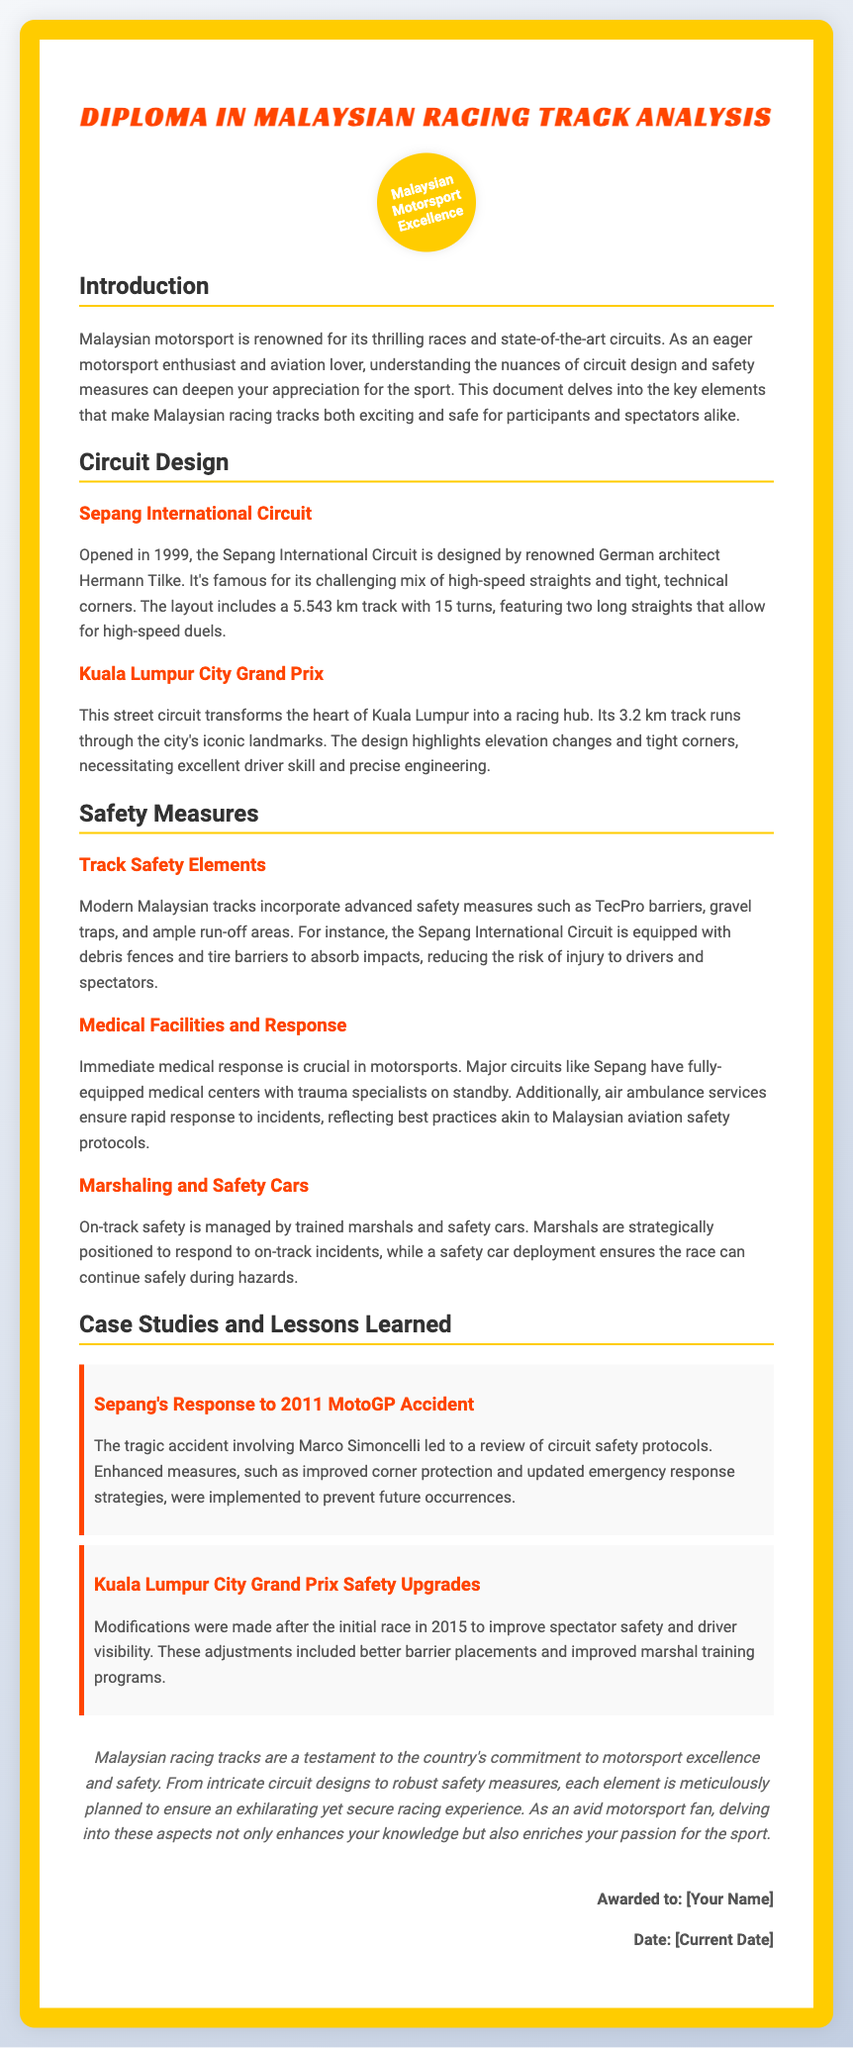What is the name of the diploma? The name of the diploma is stated in the title of the document as "Diploma in Malaysian Racing Track Analysis."
Answer: Diploma in Malaysian Racing Track Analysis Who designed the Sepang International Circuit? The designer of the Sepang International Circuit is mentioned in the document as Hermann Tilke.
Answer: Hermann Tilke What is the length of the Sepang International Circuit? The length of the Sepang International Circuit is provided in the document as 5.543 km.
Answer: 5.543 km What incident led to a review of circuit safety protocols in Sepang? The incident mentioned is the tragic accident involving Marco Simoncelli in 2011.
Answer: 2011 MotoGP Accident What type of circuit is the Kuala Lumpur City Grand Prix? The Kuala Lumpur City Grand Prix is classified as a street circuit.
Answer: Street circuit Which safety element is mentioned that absorbs impacts? The document mentions that tire barriers absorb impacts as a safety measure.
Answer: Tire barriers What year did the Sepang International Circuit open? The opening year of the Sepang International Circuit is stated in the document as 1999.
Answer: 1999 What is the purpose of air ambulance services at racing circuits? The purpose of air ambulance services is to ensure rapid response to incidents, reflecting best practices in safety.
Answer: Rapid response to incidents What is highlighted about the design of the Kuala Lumpur City Grand Prix? The design of the Kuala Lumpur City Grand Prix highlights elevation changes and tight corners.
Answer: Elevation changes and tight corners 